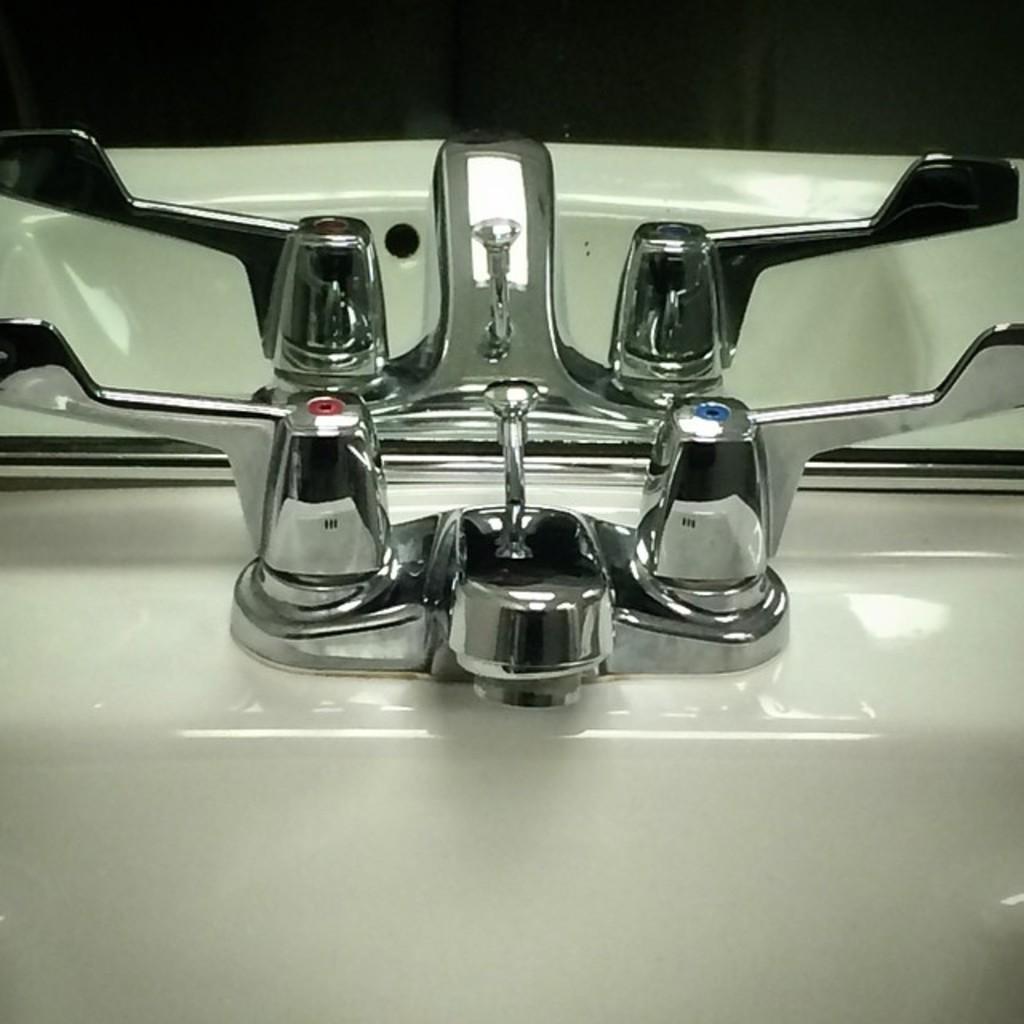Could you give a brief overview of what you see in this image? In this image there is a sink and taps, in the background there is a mirror. 